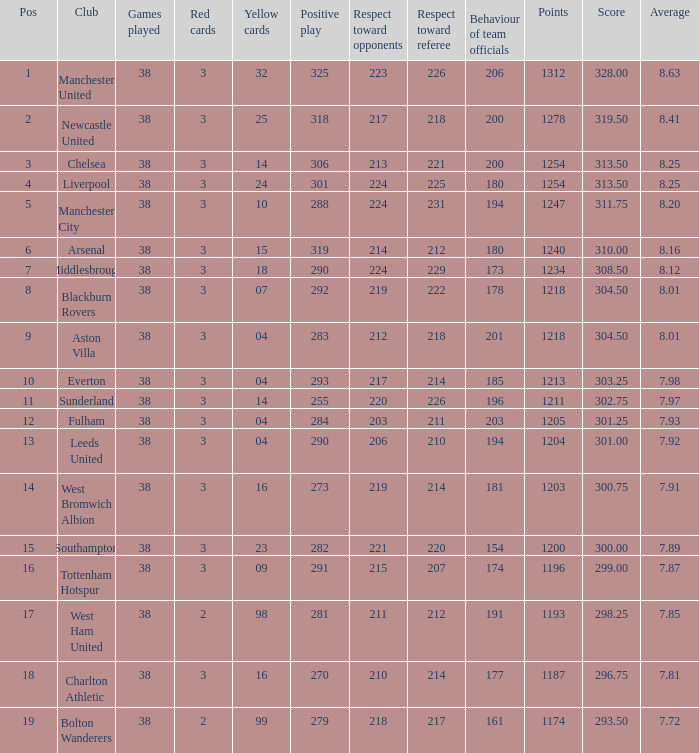Name the most red/yellow cards for positive play being 255 314.0. 